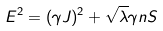<formula> <loc_0><loc_0><loc_500><loc_500>E ^ { 2 } = ( \gamma J ) ^ { 2 } + \sqrt { \lambda } \gamma n S</formula> 